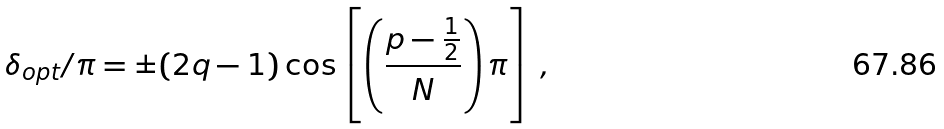<formula> <loc_0><loc_0><loc_500><loc_500>\delta _ { o p t } / \pi = \pm ( 2 q - 1 ) \cos \left [ \left ( \frac { p - \frac { 1 } { 2 } } { N } \right ) \pi \right ] \, ,</formula> 